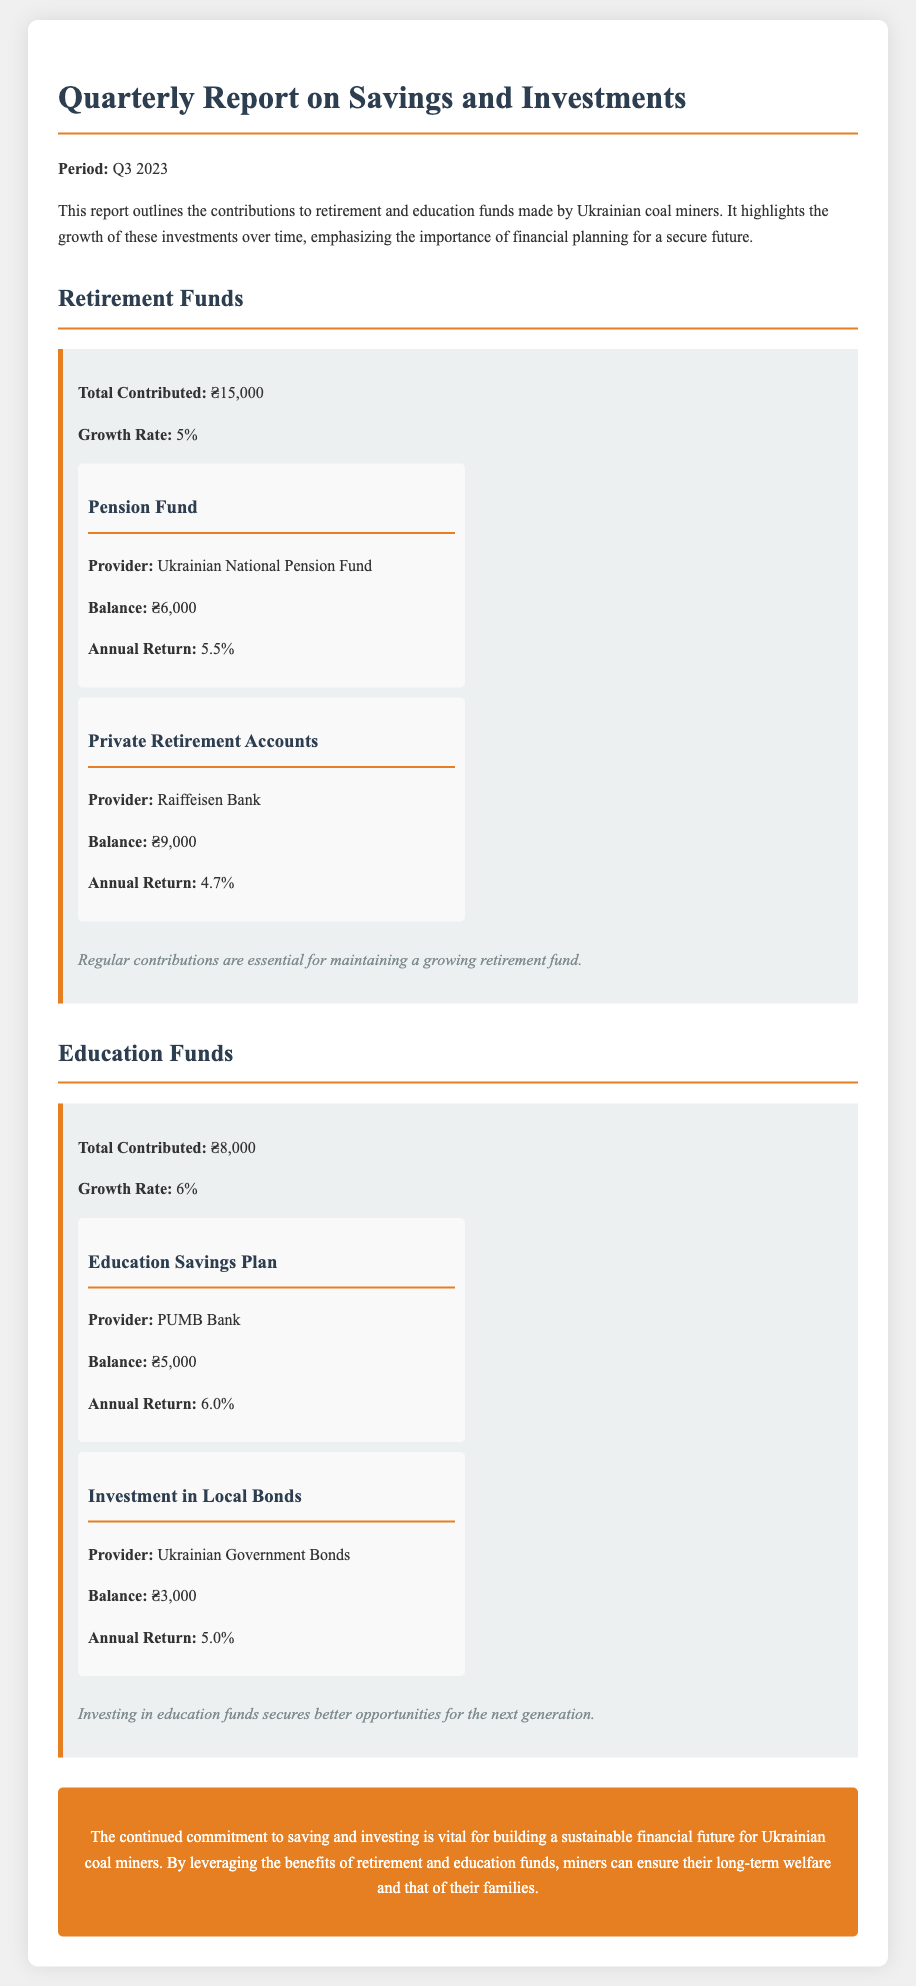What is the total contributed to retirement funds? The document states the total contributed to retirement funds is ₴15,000.
Answer: ₴15,000 What is the balance of the Pension Fund? The balance of the Pension Fund, provided by the Ukrainian National Pension Fund, is ₴6,000.
Answer: ₴6,000 What is the annual return of Private Retirement Accounts? The annual return of Private Retirement Accounts, provided by Raiffeisen Bank, is 4.7%.
Answer: 4.7% What is the total contributed to education funds? The document mentions the total contributed to education funds is ₴8,000.
Answer: ₴8,000 Which bank provides the Education Savings Plan? The Education Savings Plan is provided by PUMB Bank.
Answer: PUMB Bank What is the growth rate for education funds? The document states that the growth rate for education funds is 6%.
Answer: 6% How much is invested in local bonds? The investment in Local Bonds, provided by Ukrainian Government Bonds, has a balance of ₴3,000.
Answer: ₴3,000 What is the key takeaway regarding retirement funds? The key takeaway is that regular contributions are essential for maintaining a growing retirement fund.
Answer: Regular contributions are essential for maintaining a growing retirement fund What conclusion does the report provide regarding financial futures? The conclusion emphasizes the importance of saving and investing for a sustainable financial future.
Answer: Importance of saving and investing for a sustainable financial future 